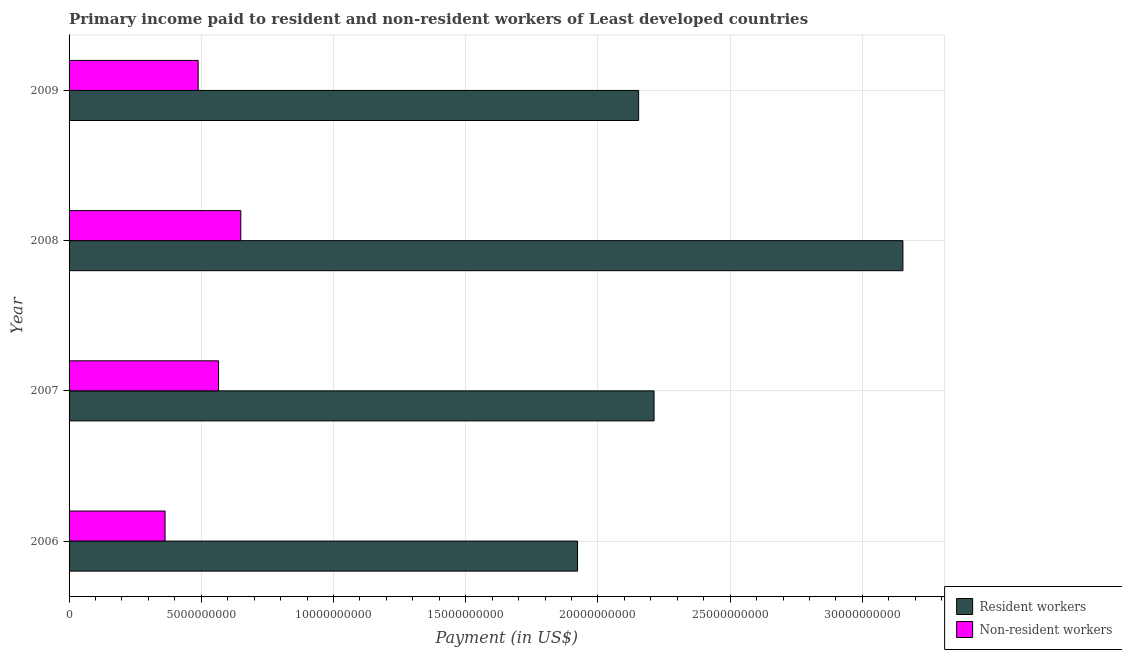How many different coloured bars are there?
Your answer should be compact. 2. Are the number of bars per tick equal to the number of legend labels?
Make the answer very short. Yes. Are the number of bars on each tick of the Y-axis equal?
Ensure brevity in your answer.  Yes. What is the label of the 2nd group of bars from the top?
Your answer should be compact. 2008. What is the payment made to resident workers in 2009?
Offer a very short reply. 2.15e+1. Across all years, what is the maximum payment made to non-resident workers?
Your response must be concise. 6.49e+09. Across all years, what is the minimum payment made to non-resident workers?
Provide a succinct answer. 3.63e+09. In which year was the payment made to non-resident workers maximum?
Offer a very short reply. 2008. What is the total payment made to resident workers in the graph?
Your response must be concise. 9.44e+1. What is the difference between the payment made to resident workers in 2008 and that in 2009?
Keep it short and to the point. 9.99e+09. What is the difference between the payment made to resident workers in 2008 and the payment made to non-resident workers in 2009?
Ensure brevity in your answer.  2.67e+1. What is the average payment made to non-resident workers per year?
Keep it short and to the point. 5.16e+09. In the year 2008, what is the difference between the payment made to non-resident workers and payment made to resident workers?
Your response must be concise. -2.50e+1. In how many years, is the payment made to non-resident workers greater than 2000000000 US$?
Offer a terse response. 4. What is the ratio of the payment made to resident workers in 2006 to that in 2008?
Make the answer very short. 0.61. Is the difference between the payment made to non-resident workers in 2006 and 2007 greater than the difference between the payment made to resident workers in 2006 and 2007?
Your response must be concise. Yes. What is the difference between the highest and the second highest payment made to non-resident workers?
Keep it short and to the point. 8.42e+08. What is the difference between the highest and the lowest payment made to resident workers?
Ensure brevity in your answer.  1.23e+1. What does the 1st bar from the top in 2007 represents?
Offer a terse response. Non-resident workers. What does the 1st bar from the bottom in 2006 represents?
Ensure brevity in your answer.  Resident workers. How many years are there in the graph?
Give a very brief answer. 4. What is the difference between two consecutive major ticks on the X-axis?
Make the answer very short. 5.00e+09. Does the graph contain any zero values?
Make the answer very short. No. Does the graph contain grids?
Give a very brief answer. Yes. Where does the legend appear in the graph?
Your answer should be very brief. Bottom right. How many legend labels are there?
Give a very brief answer. 2. How are the legend labels stacked?
Provide a succinct answer. Vertical. What is the title of the graph?
Give a very brief answer. Primary income paid to resident and non-resident workers of Least developed countries. Does "From World Bank" appear as one of the legend labels in the graph?
Offer a very short reply. No. What is the label or title of the X-axis?
Offer a terse response. Payment (in US$). What is the label or title of the Y-axis?
Make the answer very short. Year. What is the Payment (in US$) in Resident workers in 2006?
Provide a short and direct response. 1.92e+1. What is the Payment (in US$) in Non-resident workers in 2006?
Provide a short and direct response. 3.63e+09. What is the Payment (in US$) in Resident workers in 2007?
Provide a succinct answer. 2.21e+1. What is the Payment (in US$) of Non-resident workers in 2007?
Keep it short and to the point. 5.65e+09. What is the Payment (in US$) of Resident workers in 2008?
Make the answer very short. 3.15e+1. What is the Payment (in US$) in Non-resident workers in 2008?
Offer a terse response. 6.49e+09. What is the Payment (in US$) in Resident workers in 2009?
Give a very brief answer. 2.15e+1. What is the Payment (in US$) in Non-resident workers in 2009?
Make the answer very short. 4.88e+09. Across all years, what is the maximum Payment (in US$) of Resident workers?
Your answer should be compact. 3.15e+1. Across all years, what is the maximum Payment (in US$) in Non-resident workers?
Offer a very short reply. 6.49e+09. Across all years, what is the minimum Payment (in US$) in Resident workers?
Keep it short and to the point. 1.92e+1. Across all years, what is the minimum Payment (in US$) in Non-resident workers?
Your answer should be compact. 3.63e+09. What is the total Payment (in US$) of Resident workers in the graph?
Ensure brevity in your answer.  9.44e+1. What is the total Payment (in US$) in Non-resident workers in the graph?
Make the answer very short. 2.07e+1. What is the difference between the Payment (in US$) in Resident workers in 2006 and that in 2007?
Keep it short and to the point. -2.89e+09. What is the difference between the Payment (in US$) of Non-resident workers in 2006 and that in 2007?
Offer a terse response. -2.02e+09. What is the difference between the Payment (in US$) of Resident workers in 2006 and that in 2008?
Keep it short and to the point. -1.23e+1. What is the difference between the Payment (in US$) in Non-resident workers in 2006 and that in 2008?
Your response must be concise. -2.86e+09. What is the difference between the Payment (in US$) of Resident workers in 2006 and that in 2009?
Your response must be concise. -2.31e+09. What is the difference between the Payment (in US$) in Non-resident workers in 2006 and that in 2009?
Provide a succinct answer. -1.25e+09. What is the difference between the Payment (in US$) in Resident workers in 2007 and that in 2008?
Offer a terse response. -9.41e+09. What is the difference between the Payment (in US$) in Non-resident workers in 2007 and that in 2008?
Provide a succinct answer. -8.42e+08. What is the difference between the Payment (in US$) of Resident workers in 2007 and that in 2009?
Offer a very short reply. 5.83e+08. What is the difference between the Payment (in US$) of Non-resident workers in 2007 and that in 2009?
Ensure brevity in your answer.  7.71e+08. What is the difference between the Payment (in US$) in Resident workers in 2008 and that in 2009?
Keep it short and to the point. 9.99e+09. What is the difference between the Payment (in US$) of Non-resident workers in 2008 and that in 2009?
Offer a very short reply. 1.61e+09. What is the difference between the Payment (in US$) of Resident workers in 2006 and the Payment (in US$) of Non-resident workers in 2007?
Ensure brevity in your answer.  1.36e+1. What is the difference between the Payment (in US$) in Resident workers in 2006 and the Payment (in US$) in Non-resident workers in 2008?
Your answer should be compact. 1.27e+1. What is the difference between the Payment (in US$) of Resident workers in 2006 and the Payment (in US$) of Non-resident workers in 2009?
Provide a short and direct response. 1.43e+1. What is the difference between the Payment (in US$) in Resident workers in 2007 and the Payment (in US$) in Non-resident workers in 2008?
Offer a very short reply. 1.56e+1. What is the difference between the Payment (in US$) of Resident workers in 2007 and the Payment (in US$) of Non-resident workers in 2009?
Give a very brief answer. 1.72e+1. What is the difference between the Payment (in US$) in Resident workers in 2008 and the Payment (in US$) in Non-resident workers in 2009?
Your response must be concise. 2.67e+1. What is the average Payment (in US$) in Resident workers per year?
Provide a short and direct response. 2.36e+1. What is the average Payment (in US$) of Non-resident workers per year?
Your answer should be compact. 5.16e+09. In the year 2006, what is the difference between the Payment (in US$) of Resident workers and Payment (in US$) of Non-resident workers?
Your answer should be very brief. 1.56e+1. In the year 2007, what is the difference between the Payment (in US$) of Resident workers and Payment (in US$) of Non-resident workers?
Provide a succinct answer. 1.65e+1. In the year 2008, what is the difference between the Payment (in US$) of Resident workers and Payment (in US$) of Non-resident workers?
Your answer should be compact. 2.50e+1. In the year 2009, what is the difference between the Payment (in US$) in Resident workers and Payment (in US$) in Non-resident workers?
Your answer should be compact. 1.67e+1. What is the ratio of the Payment (in US$) of Resident workers in 2006 to that in 2007?
Your answer should be very brief. 0.87. What is the ratio of the Payment (in US$) in Non-resident workers in 2006 to that in 2007?
Your answer should be very brief. 0.64. What is the ratio of the Payment (in US$) in Resident workers in 2006 to that in 2008?
Your answer should be very brief. 0.61. What is the ratio of the Payment (in US$) of Non-resident workers in 2006 to that in 2008?
Provide a short and direct response. 0.56. What is the ratio of the Payment (in US$) in Resident workers in 2006 to that in 2009?
Your answer should be very brief. 0.89. What is the ratio of the Payment (in US$) of Non-resident workers in 2006 to that in 2009?
Offer a terse response. 0.74. What is the ratio of the Payment (in US$) in Resident workers in 2007 to that in 2008?
Your answer should be compact. 0.7. What is the ratio of the Payment (in US$) in Non-resident workers in 2007 to that in 2008?
Ensure brevity in your answer.  0.87. What is the ratio of the Payment (in US$) in Resident workers in 2007 to that in 2009?
Keep it short and to the point. 1.03. What is the ratio of the Payment (in US$) in Non-resident workers in 2007 to that in 2009?
Your response must be concise. 1.16. What is the ratio of the Payment (in US$) in Resident workers in 2008 to that in 2009?
Your response must be concise. 1.46. What is the ratio of the Payment (in US$) of Non-resident workers in 2008 to that in 2009?
Your answer should be compact. 1.33. What is the difference between the highest and the second highest Payment (in US$) in Resident workers?
Your answer should be very brief. 9.41e+09. What is the difference between the highest and the second highest Payment (in US$) of Non-resident workers?
Your response must be concise. 8.42e+08. What is the difference between the highest and the lowest Payment (in US$) in Resident workers?
Ensure brevity in your answer.  1.23e+1. What is the difference between the highest and the lowest Payment (in US$) in Non-resident workers?
Your answer should be very brief. 2.86e+09. 